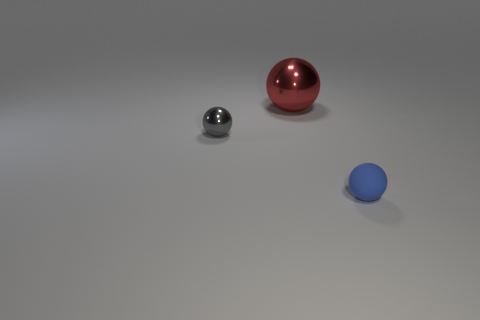Does the large red metallic object have the same shape as the tiny metal thing?
Provide a succinct answer. Yes. There is a object that is in front of the large red sphere and behind the rubber object; what material is it?
Ensure brevity in your answer.  Metal. What size is the red shiny ball?
Ensure brevity in your answer.  Large. There is another small metallic thing that is the same shape as the red thing; what color is it?
Your response must be concise. Gray. Is there any other thing that is the same color as the big sphere?
Give a very brief answer. No. There is a shiny ball that is behind the gray ball; is its size the same as the thing that is in front of the gray thing?
Offer a very short reply. No. Are there an equal number of gray metallic objects on the right side of the gray sphere and blue balls behind the red sphere?
Give a very brief answer. Yes. Is the size of the gray ball the same as the blue matte ball in front of the big ball?
Keep it short and to the point. Yes. There is a shiny object left of the big red thing; is there a big shiny ball in front of it?
Provide a short and direct response. No. Is there another matte thing that has the same shape as the big thing?
Keep it short and to the point. Yes. 